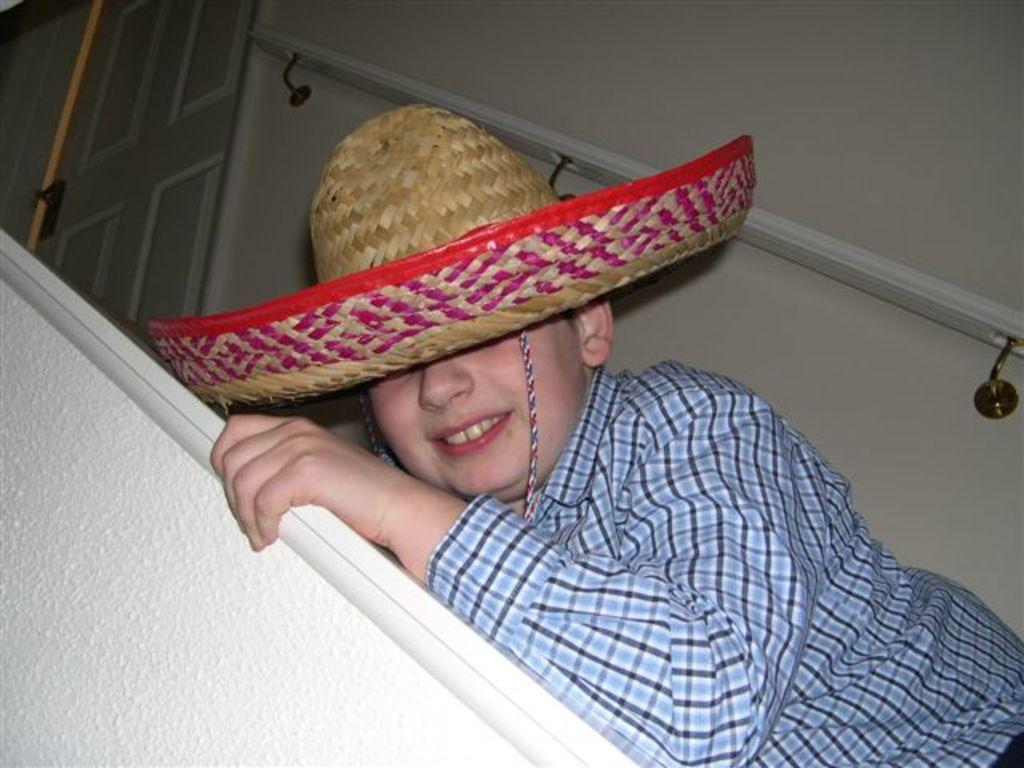What is the main subject in the center of the image? There is a boy in the center of the image. What is the boy wearing on his head? The boy is wearing a hat. What can be seen in the background of the image? There is a door, a door handle, and a wall in the background of the image. What type of wax can be seen dripping from the geese in the image? There are no geese present in the image, and therefore no wax can be seen dripping from them. 